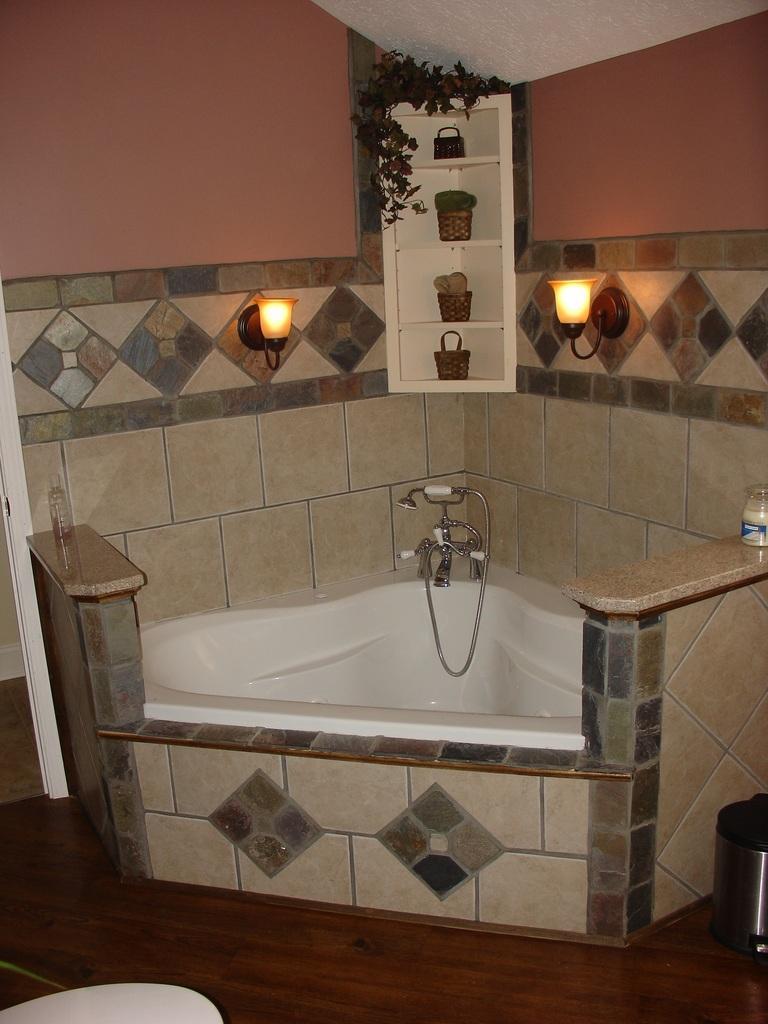Can you describe this image briefly? In this image I can see water tap, bathtub, few lights, few baskets, a plant, a water bottle and here I can see a dustbin. I can also see a jar over here. 